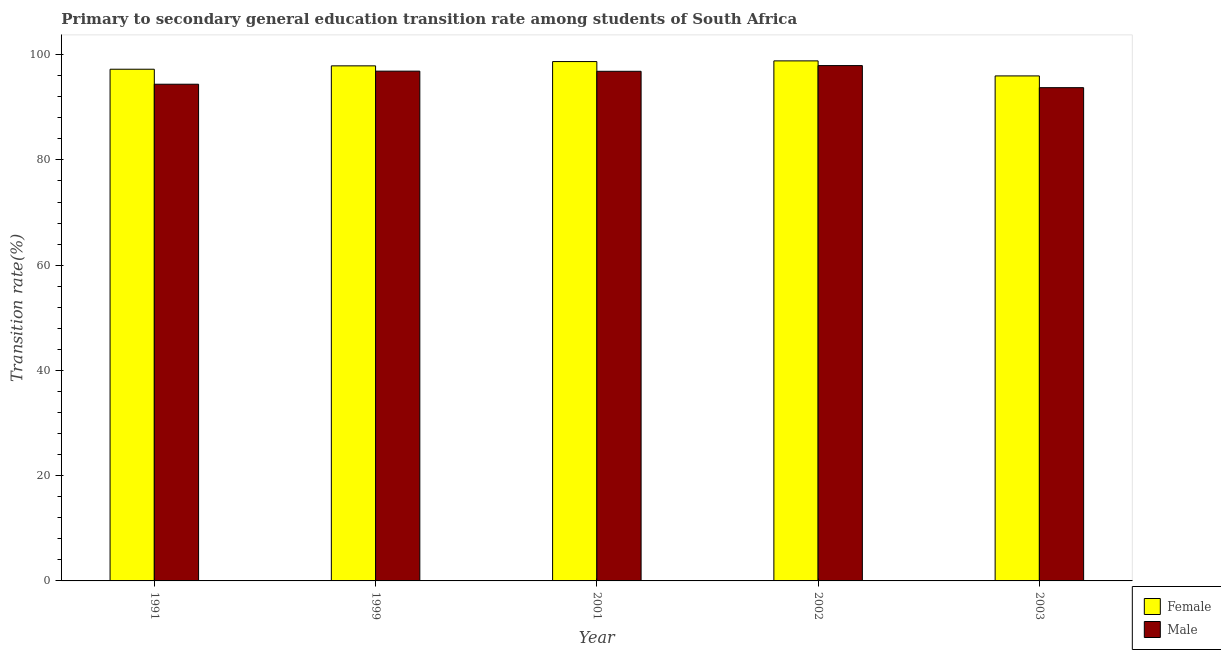How many groups of bars are there?
Your response must be concise. 5. Are the number of bars per tick equal to the number of legend labels?
Provide a short and direct response. Yes. How many bars are there on the 2nd tick from the left?
Ensure brevity in your answer.  2. How many bars are there on the 5th tick from the right?
Your answer should be very brief. 2. What is the label of the 2nd group of bars from the left?
Keep it short and to the point. 1999. What is the transition rate among female students in 2002?
Offer a very short reply. 98.82. Across all years, what is the maximum transition rate among female students?
Give a very brief answer. 98.82. Across all years, what is the minimum transition rate among female students?
Provide a succinct answer. 95.96. What is the total transition rate among male students in the graph?
Offer a very short reply. 479.73. What is the difference between the transition rate among female students in 2001 and that in 2003?
Make the answer very short. 2.73. What is the difference between the transition rate among male students in 2001 and the transition rate among female students in 1999?
Keep it short and to the point. -0.03. What is the average transition rate among female students per year?
Your answer should be very brief. 97.71. What is the ratio of the transition rate among male students in 1991 to that in 1999?
Ensure brevity in your answer.  0.97. What is the difference between the highest and the second highest transition rate among male students?
Give a very brief answer. 1.06. What is the difference between the highest and the lowest transition rate among female students?
Your response must be concise. 2.86. In how many years, is the transition rate among male students greater than the average transition rate among male students taken over all years?
Give a very brief answer. 3. Is the sum of the transition rate among female students in 2002 and 2003 greater than the maximum transition rate among male students across all years?
Ensure brevity in your answer.  Yes. What does the 2nd bar from the left in 1999 represents?
Ensure brevity in your answer.  Male. How many years are there in the graph?
Give a very brief answer. 5. What is the difference between two consecutive major ticks on the Y-axis?
Give a very brief answer. 20. Are the values on the major ticks of Y-axis written in scientific E-notation?
Make the answer very short. No. Does the graph contain grids?
Your answer should be very brief. No. How many legend labels are there?
Offer a terse response. 2. How are the legend labels stacked?
Keep it short and to the point. Vertical. What is the title of the graph?
Offer a very short reply. Primary to secondary general education transition rate among students of South Africa. What is the label or title of the Y-axis?
Provide a short and direct response. Transition rate(%). What is the Transition rate(%) in Female in 1991?
Your answer should be very brief. 97.23. What is the Transition rate(%) in Male in 1991?
Give a very brief answer. 94.38. What is the Transition rate(%) of Female in 1999?
Make the answer very short. 97.87. What is the Transition rate(%) in Male in 1999?
Ensure brevity in your answer.  96.86. What is the Transition rate(%) in Female in 2001?
Your response must be concise. 98.68. What is the Transition rate(%) of Male in 2001?
Offer a very short reply. 96.84. What is the Transition rate(%) in Female in 2002?
Your response must be concise. 98.82. What is the Transition rate(%) in Male in 2002?
Offer a terse response. 97.92. What is the Transition rate(%) in Female in 2003?
Make the answer very short. 95.96. What is the Transition rate(%) in Male in 2003?
Ensure brevity in your answer.  93.73. Across all years, what is the maximum Transition rate(%) in Female?
Provide a short and direct response. 98.82. Across all years, what is the maximum Transition rate(%) in Male?
Your response must be concise. 97.92. Across all years, what is the minimum Transition rate(%) in Female?
Provide a succinct answer. 95.96. Across all years, what is the minimum Transition rate(%) in Male?
Provide a short and direct response. 93.73. What is the total Transition rate(%) of Female in the graph?
Keep it short and to the point. 488.56. What is the total Transition rate(%) in Male in the graph?
Give a very brief answer. 479.73. What is the difference between the Transition rate(%) in Female in 1991 and that in 1999?
Give a very brief answer. -0.64. What is the difference between the Transition rate(%) of Male in 1991 and that in 1999?
Your answer should be very brief. -2.48. What is the difference between the Transition rate(%) of Female in 1991 and that in 2001?
Provide a short and direct response. -1.45. What is the difference between the Transition rate(%) of Male in 1991 and that in 2001?
Give a very brief answer. -2.46. What is the difference between the Transition rate(%) in Female in 1991 and that in 2002?
Your answer should be compact. -1.59. What is the difference between the Transition rate(%) of Male in 1991 and that in 2002?
Your answer should be very brief. -3.54. What is the difference between the Transition rate(%) of Female in 1991 and that in 2003?
Keep it short and to the point. 1.27. What is the difference between the Transition rate(%) in Male in 1991 and that in 2003?
Provide a succinct answer. 0.65. What is the difference between the Transition rate(%) in Female in 1999 and that in 2001?
Your answer should be very brief. -0.81. What is the difference between the Transition rate(%) of Male in 1999 and that in 2001?
Give a very brief answer. 0.03. What is the difference between the Transition rate(%) of Female in 1999 and that in 2002?
Offer a very short reply. -0.95. What is the difference between the Transition rate(%) of Male in 1999 and that in 2002?
Provide a succinct answer. -1.06. What is the difference between the Transition rate(%) of Female in 1999 and that in 2003?
Your response must be concise. 1.91. What is the difference between the Transition rate(%) in Male in 1999 and that in 2003?
Your answer should be very brief. 3.14. What is the difference between the Transition rate(%) of Female in 2001 and that in 2002?
Keep it short and to the point. -0.13. What is the difference between the Transition rate(%) in Male in 2001 and that in 2002?
Provide a succinct answer. -1.08. What is the difference between the Transition rate(%) in Female in 2001 and that in 2003?
Make the answer very short. 2.73. What is the difference between the Transition rate(%) in Male in 2001 and that in 2003?
Your answer should be very brief. 3.11. What is the difference between the Transition rate(%) in Female in 2002 and that in 2003?
Ensure brevity in your answer.  2.86. What is the difference between the Transition rate(%) of Male in 2002 and that in 2003?
Give a very brief answer. 4.19. What is the difference between the Transition rate(%) in Female in 1991 and the Transition rate(%) in Male in 1999?
Offer a terse response. 0.37. What is the difference between the Transition rate(%) of Female in 1991 and the Transition rate(%) of Male in 2001?
Your answer should be very brief. 0.39. What is the difference between the Transition rate(%) of Female in 1991 and the Transition rate(%) of Male in 2002?
Give a very brief answer. -0.69. What is the difference between the Transition rate(%) of Female in 1991 and the Transition rate(%) of Male in 2003?
Give a very brief answer. 3.5. What is the difference between the Transition rate(%) in Female in 1999 and the Transition rate(%) in Male in 2001?
Provide a short and direct response. 1.03. What is the difference between the Transition rate(%) in Female in 1999 and the Transition rate(%) in Male in 2002?
Keep it short and to the point. -0.05. What is the difference between the Transition rate(%) of Female in 1999 and the Transition rate(%) of Male in 2003?
Your answer should be compact. 4.14. What is the difference between the Transition rate(%) in Female in 2001 and the Transition rate(%) in Male in 2002?
Ensure brevity in your answer.  0.76. What is the difference between the Transition rate(%) of Female in 2001 and the Transition rate(%) of Male in 2003?
Ensure brevity in your answer.  4.96. What is the difference between the Transition rate(%) of Female in 2002 and the Transition rate(%) of Male in 2003?
Provide a succinct answer. 5.09. What is the average Transition rate(%) in Female per year?
Your response must be concise. 97.71. What is the average Transition rate(%) in Male per year?
Make the answer very short. 95.95. In the year 1991, what is the difference between the Transition rate(%) of Female and Transition rate(%) of Male?
Provide a succinct answer. 2.85. In the year 1999, what is the difference between the Transition rate(%) in Female and Transition rate(%) in Male?
Your response must be concise. 1.01. In the year 2001, what is the difference between the Transition rate(%) in Female and Transition rate(%) in Male?
Offer a terse response. 1.85. In the year 2002, what is the difference between the Transition rate(%) of Female and Transition rate(%) of Male?
Offer a very short reply. 0.89. In the year 2003, what is the difference between the Transition rate(%) in Female and Transition rate(%) in Male?
Provide a succinct answer. 2.23. What is the ratio of the Transition rate(%) in Male in 1991 to that in 1999?
Make the answer very short. 0.97. What is the ratio of the Transition rate(%) in Male in 1991 to that in 2001?
Give a very brief answer. 0.97. What is the ratio of the Transition rate(%) of Male in 1991 to that in 2002?
Your answer should be very brief. 0.96. What is the ratio of the Transition rate(%) of Female in 1991 to that in 2003?
Offer a terse response. 1.01. What is the ratio of the Transition rate(%) in Male in 1991 to that in 2003?
Offer a very short reply. 1.01. What is the ratio of the Transition rate(%) of Female in 1999 to that in 2001?
Keep it short and to the point. 0.99. What is the ratio of the Transition rate(%) of Female in 1999 to that in 2003?
Ensure brevity in your answer.  1.02. What is the ratio of the Transition rate(%) in Male in 1999 to that in 2003?
Your response must be concise. 1.03. What is the ratio of the Transition rate(%) of Female in 2001 to that in 2002?
Offer a terse response. 1. What is the ratio of the Transition rate(%) in Male in 2001 to that in 2002?
Offer a terse response. 0.99. What is the ratio of the Transition rate(%) in Female in 2001 to that in 2003?
Provide a succinct answer. 1.03. What is the ratio of the Transition rate(%) in Male in 2001 to that in 2003?
Offer a very short reply. 1.03. What is the ratio of the Transition rate(%) in Female in 2002 to that in 2003?
Your answer should be compact. 1.03. What is the ratio of the Transition rate(%) in Male in 2002 to that in 2003?
Ensure brevity in your answer.  1.04. What is the difference between the highest and the second highest Transition rate(%) of Female?
Your answer should be very brief. 0.13. What is the difference between the highest and the second highest Transition rate(%) in Male?
Provide a short and direct response. 1.06. What is the difference between the highest and the lowest Transition rate(%) in Female?
Your answer should be compact. 2.86. What is the difference between the highest and the lowest Transition rate(%) in Male?
Ensure brevity in your answer.  4.19. 